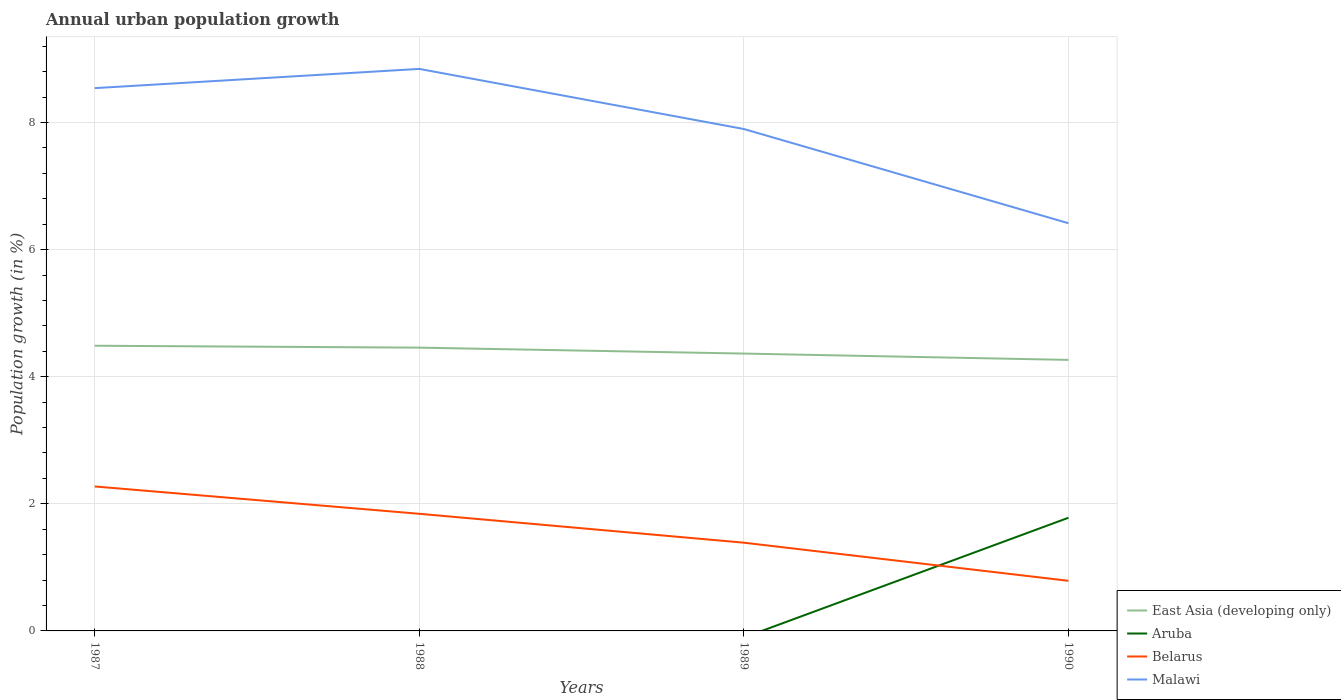How many different coloured lines are there?
Your answer should be compact. 4. Is the number of lines equal to the number of legend labels?
Offer a terse response. No. Across all years, what is the maximum percentage of urban population growth in East Asia (developing only)?
Provide a succinct answer. 4.27. What is the total percentage of urban population growth in Belarus in the graph?
Provide a short and direct response. 0.89. What is the difference between the highest and the second highest percentage of urban population growth in Malawi?
Make the answer very short. 2.43. What is the difference between two consecutive major ticks on the Y-axis?
Ensure brevity in your answer.  2. Does the graph contain any zero values?
Keep it short and to the point. Yes. Does the graph contain grids?
Offer a terse response. Yes. How many legend labels are there?
Ensure brevity in your answer.  4. How are the legend labels stacked?
Make the answer very short. Vertical. What is the title of the graph?
Keep it short and to the point. Annual urban population growth. What is the label or title of the Y-axis?
Your answer should be very brief. Population growth (in %). What is the Population growth (in %) in East Asia (developing only) in 1987?
Offer a terse response. 4.49. What is the Population growth (in %) of Belarus in 1987?
Make the answer very short. 2.27. What is the Population growth (in %) in Malawi in 1987?
Make the answer very short. 8.54. What is the Population growth (in %) of East Asia (developing only) in 1988?
Your answer should be very brief. 4.46. What is the Population growth (in %) in Belarus in 1988?
Your response must be concise. 1.84. What is the Population growth (in %) of Malawi in 1988?
Provide a short and direct response. 8.84. What is the Population growth (in %) in East Asia (developing only) in 1989?
Keep it short and to the point. 4.36. What is the Population growth (in %) of Belarus in 1989?
Give a very brief answer. 1.39. What is the Population growth (in %) in Malawi in 1989?
Your response must be concise. 7.9. What is the Population growth (in %) of East Asia (developing only) in 1990?
Provide a succinct answer. 4.27. What is the Population growth (in %) in Aruba in 1990?
Your response must be concise. 1.78. What is the Population growth (in %) in Belarus in 1990?
Your response must be concise. 0.79. What is the Population growth (in %) of Malawi in 1990?
Make the answer very short. 6.42. Across all years, what is the maximum Population growth (in %) of East Asia (developing only)?
Your response must be concise. 4.49. Across all years, what is the maximum Population growth (in %) of Aruba?
Your answer should be very brief. 1.78. Across all years, what is the maximum Population growth (in %) in Belarus?
Make the answer very short. 2.27. Across all years, what is the maximum Population growth (in %) in Malawi?
Provide a succinct answer. 8.84. Across all years, what is the minimum Population growth (in %) of East Asia (developing only)?
Provide a short and direct response. 4.27. Across all years, what is the minimum Population growth (in %) of Aruba?
Offer a very short reply. 0. Across all years, what is the minimum Population growth (in %) of Belarus?
Your answer should be compact. 0.79. Across all years, what is the minimum Population growth (in %) of Malawi?
Keep it short and to the point. 6.42. What is the total Population growth (in %) in East Asia (developing only) in the graph?
Provide a short and direct response. 17.58. What is the total Population growth (in %) of Aruba in the graph?
Your answer should be compact. 1.78. What is the total Population growth (in %) of Belarus in the graph?
Give a very brief answer. 6.29. What is the total Population growth (in %) of Malawi in the graph?
Your response must be concise. 31.7. What is the difference between the Population growth (in %) of Belarus in 1987 and that in 1988?
Offer a very short reply. 0.43. What is the difference between the Population growth (in %) in Malawi in 1987 and that in 1988?
Give a very brief answer. -0.3. What is the difference between the Population growth (in %) in East Asia (developing only) in 1987 and that in 1989?
Keep it short and to the point. 0.12. What is the difference between the Population growth (in %) of Belarus in 1987 and that in 1989?
Your answer should be very brief. 0.89. What is the difference between the Population growth (in %) in Malawi in 1987 and that in 1989?
Your answer should be compact. 0.64. What is the difference between the Population growth (in %) in East Asia (developing only) in 1987 and that in 1990?
Provide a short and direct response. 0.22. What is the difference between the Population growth (in %) in Belarus in 1987 and that in 1990?
Provide a succinct answer. 1.48. What is the difference between the Population growth (in %) in Malawi in 1987 and that in 1990?
Your answer should be very brief. 2.13. What is the difference between the Population growth (in %) of East Asia (developing only) in 1988 and that in 1989?
Offer a very short reply. 0.09. What is the difference between the Population growth (in %) in Belarus in 1988 and that in 1989?
Your answer should be very brief. 0.45. What is the difference between the Population growth (in %) of Malawi in 1988 and that in 1989?
Provide a short and direct response. 0.95. What is the difference between the Population growth (in %) of East Asia (developing only) in 1988 and that in 1990?
Ensure brevity in your answer.  0.19. What is the difference between the Population growth (in %) in Belarus in 1988 and that in 1990?
Your response must be concise. 1.05. What is the difference between the Population growth (in %) in Malawi in 1988 and that in 1990?
Offer a very short reply. 2.43. What is the difference between the Population growth (in %) of East Asia (developing only) in 1989 and that in 1990?
Your answer should be compact. 0.1. What is the difference between the Population growth (in %) of Belarus in 1989 and that in 1990?
Your response must be concise. 0.6. What is the difference between the Population growth (in %) in Malawi in 1989 and that in 1990?
Offer a terse response. 1.48. What is the difference between the Population growth (in %) in East Asia (developing only) in 1987 and the Population growth (in %) in Belarus in 1988?
Offer a very short reply. 2.65. What is the difference between the Population growth (in %) in East Asia (developing only) in 1987 and the Population growth (in %) in Malawi in 1988?
Give a very brief answer. -4.36. What is the difference between the Population growth (in %) in Belarus in 1987 and the Population growth (in %) in Malawi in 1988?
Make the answer very short. -6.57. What is the difference between the Population growth (in %) in East Asia (developing only) in 1987 and the Population growth (in %) in Belarus in 1989?
Offer a very short reply. 3.1. What is the difference between the Population growth (in %) of East Asia (developing only) in 1987 and the Population growth (in %) of Malawi in 1989?
Provide a short and direct response. -3.41. What is the difference between the Population growth (in %) in Belarus in 1987 and the Population growth (in %) in Malawi in 1989?
Give a very brief answer. -5.63. What is the difference between the Population growth (in %) of East Asia (developing only) in 1987 and the Population growth (in %) of Aruba in 1990?
Offer a very short reply. 2.71. What is the difference between the Population growth (in %) in East Asia (developing only) in 1987 and the Population growth (in %) in Belarus in 1990?
Keep it short and to the point. 3.7. What is the difference between the Population growth (in %) of East Asia (developing only) in 1987 and the Population growth (in %) of Malawi in 1990?
Your response must be concise. -1.93. What is the difference between the Population growth (in %) in Belarus in 1987 and the Population growth (in %) in Malawi in 1990?
Your answer should be very brief. -4.14. What is the difference between the Population growth (in %) in East Asia (developing only) in 1988 and the Population growth (in %) in Belarus in 1989?
Provide a succinct answer. 3.07. What is the difference between the Population growth (in %) of East Asia (developing only) in 1988 and the Population growth (in %) of Malawi in 1989?
Your answer should be very brief. -3.44. What is the difference between the Population growth (in %) in Belarus in 1988 and the Population growth (in %) in Malawi in 1989?
Make the answer very short. -6.06. What is the difference between the Population growth (in %) of East Asia (developing only) in 1988 and the Population growth (in %) of Aruba in 1990?
Offer a very short reply. 2.68. What is the difference between the Population growth (in %) of East Asia (developing only) in 1988 and the Population growth (in %) of Belarus in 1990?
Your answer should be compact. 3.67. What is the difference between the Population growth (in %) in East Asia (developing only) in 1988 and the Population growth (in %) in Malawi in 1990?
Offer a terse response. -1.96. What is the difference between the Population growth (in %) of Belarus in 1988 and the Population growth (in %) of Malawi in 1990?
Offer a very short reply. -4.57. What is the difference between the Population growth (in %) in East Asia (developing only) in 1989 and the Population growth (in %) in Aruba in 1990?
Offer a terse response. 2.58. What is the difference between the Population growth (in %) of East Asia (developing only) in 1989 and the Population growth (in %) of Belarus in 1990?
Provide a short and direct response. 3.58. What is the difference between the Population growth (in %) of East Asia (developing only) in 1989 and the Population growth (in %) of Malawi in 1990?
Ensure brevity in your answer.  -2.05. What is the difference between the Population growth (in %) of Belarus in 1989 and the Population growth (in %) of Malawi in 1990?
Your response must be concise. -5.03. What is the average Population growth (in %) of East Asia (developing only) per year?
Keep it short and to the point. 4.39. What is the average Population growth (in %) of Aruba per year?
Offer a terse response. 0.45. What is the average Population growth (in %) in Belarus per year?
Give a very brief answer. 1.57. What is the average Population growth (in %) of Malawi per year?
Your answer should be very brief. 7.93. In the year 1987, what is the difference between the Population growth (in %) in East Asia (developing only) and Population growth (in %) in Belarus?
Give a very brief answer. 2.21. In the year 1987, what is the difference between the Population growth (in %) in East Asia (developing only) and Population growth (in %) in Malawi?
Offer a terse response. -4.05. In the year 1987, what is the difference between the Population growth (in %) in Belarus and Population growth (in %) in Malawi?
Ensure brevity in your answer.  -6.27. In the year 1988, what is the difference between the Population growth (in %) of East Asia (developing only) and Population growth (in %) of Belarus?
Make the answer very short. 2.62. In the year 1988, what is the difference between the Population growth (in %) of East Asia (developing only) and Population growth (in %) of Malawi?
Provide a short and direct response. -4.39. In the year 1988, what is the difference between the Population growth (in %) in Belarus and Population growth (in %) in Malawi?
Provide a succinct answer. -7. In the year 1989, what is the difference between the Population growth (in %) in East Asia (developing only) and Population growth (in %) in Belarus?
Make the answer very short. 2.98. In the year 1989, what is the difference between the Population growth (in %) of East Asia (developing only) and Population growth (in %) of Malawi?
Your response must be concise. -3.53. In the year 1989, what is the difference between the Population growth (in %) of Belarus and Population growth (in %) of Malawi?
Offer a terse response. -6.51. In the year 1990, what is the difference between the Population growth (in %) in East Asia (developing only) and Population growth (in %) in Aruba?
Your answer should be compact. 2.48. In the year 1990, what is the difference between the Population growth (in %) of East Asia (developing only) and Population growth (in %) of Belarus?
Make the answer very short. 3.48. In the year 1990, what is the difference between the Population growth (in %) of East Asia (developing only) and Population growth (in %) of Malawi?
Your response must be concise. -2.15. In the year 1990, what is the difference between the Population growth (in %) of Aruba and Population growth (in %) of Belarus?
Offer a terse response. 0.99. In the year 1990, what is the difference between the Population growth (in %) of Aruba and Population growth (in %) of Malawi?
Make the answer very short. -4.63. In the year 1990, what is the difference between the Population growth (in %) of Belarus and Population growth (in %) of Malawi?
Your answer should be very brief. -5.63. What is the ratio of the Population growth (in %) of East Asia (developing only) in 1987 to that in 1988?
Give a very brief answer. 1.01. What is the ratio of the Population growth (in %) in Belarus in 1987 to that in 1988?
Your answer should be compact. 1.23. What is the ratio of the Population growth (in %) of Malawi in 1987 to that in 1988?
Give a very brief answer. 0.97. What is the ratio of the Population growth (in %) of East Asia (developing only) in 1987 to that in 1989?
Your response must be concise. 1.03. What is the ratio of the Population growth (in %) of Belarus in 1987 to that in 1989?
Provide a succinct answer. 1.64. What is the ratio of the Population growth (in %) in Malawi in 1987 to that in 1989?
Offer a terse response. 1.08. What is the ratio of the Population growth (in %) in East Asia (developing only) in 1987 to that in 1990?
Make the answer very short. 1.05. What is the ratio of the Population growth (in %) of Belarus in 1987 to that in 1990?
Provide a short and direct response. 2.88. What is the ratio of the Population growth (in %) in Malawi in 1987 to that in 1990?
Offer a terse response. 1.33. What is the ratio of the Population growth (in %) in East Asia (developing only) in 1988 to that in 1989?
Make the answer very short. 1.02. What is the ratio of the Population growth (in %) in Belarus in 1988 to that in 1989?
Give a very brief answer. 1.33. What is the ratio of the Population growth (in %) of Malawi in 1988 to that in 1989?
Provide a short and direct response. 1.12. What is the ratio of the Population growth (in %) of East Asia (developing only) in 1988 to that in 1990?
Your answer should be very brief. 1.05. What is the ratio of the Population growth (in %) of Belarus in 1988 to that in 1990?
Keep it short and to the point. 2.34. What is the ratio of the Population growth (in %) in Malawi in 1988 to that in 1990?
Offer a very short reply. 1.38. What is the ratio of the Population growth (in %) of East Asia (developing only) in 1989 to that in 1990?
Offer a terse response. 1.02. What is the ratio of the Population growth (in %) of Belarus in 1989 to that in 1990?
Make the answer very short. 1.76. What is the ratio of the Population growth (in %) of Malawi in 1989 to that in 1990?
Provide a succinct answer. 1.23. What is the difference between the highest and the second highest Population growth (in %) in Belarus?
Offer a very short reply. 0.43. What is the difference between the highest and the second highest Population growth (in %) in Malawi?
Offer a terse response. 0.3. What is the difference between the highest and the lowest Population growth (in %) in East Asia (developing only)?
Offer a terse response. 0.22. What is the difference between the highest and the lowest Population growth (in %) in Aruba?
Provide a succinct answer. 1.78. What is the difference between the highest and the lowest Population growth (in %) in Belarus?
Ensure brevity in your answer.  1.48. What is the difference between the highest and the lowest Population growth (in %) of Malawi?
Ensure brevity in your answer.  2.43. 